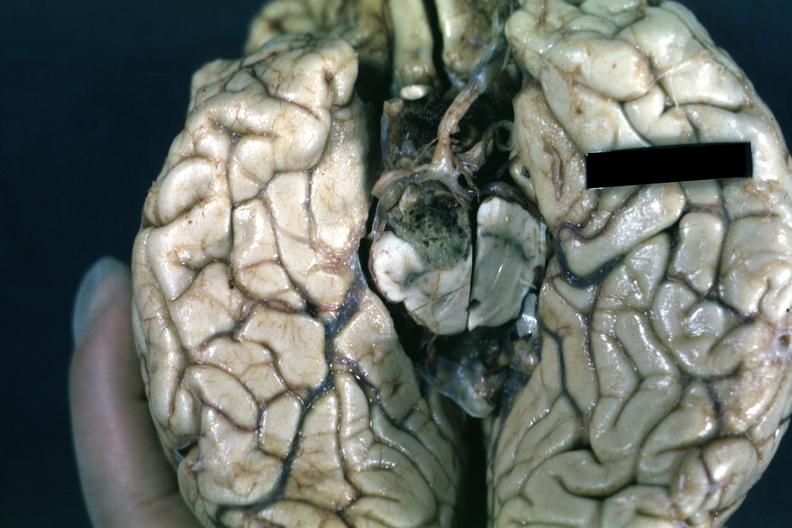s retroperitoneum present?
Answer the question using a single word or phrase. No 